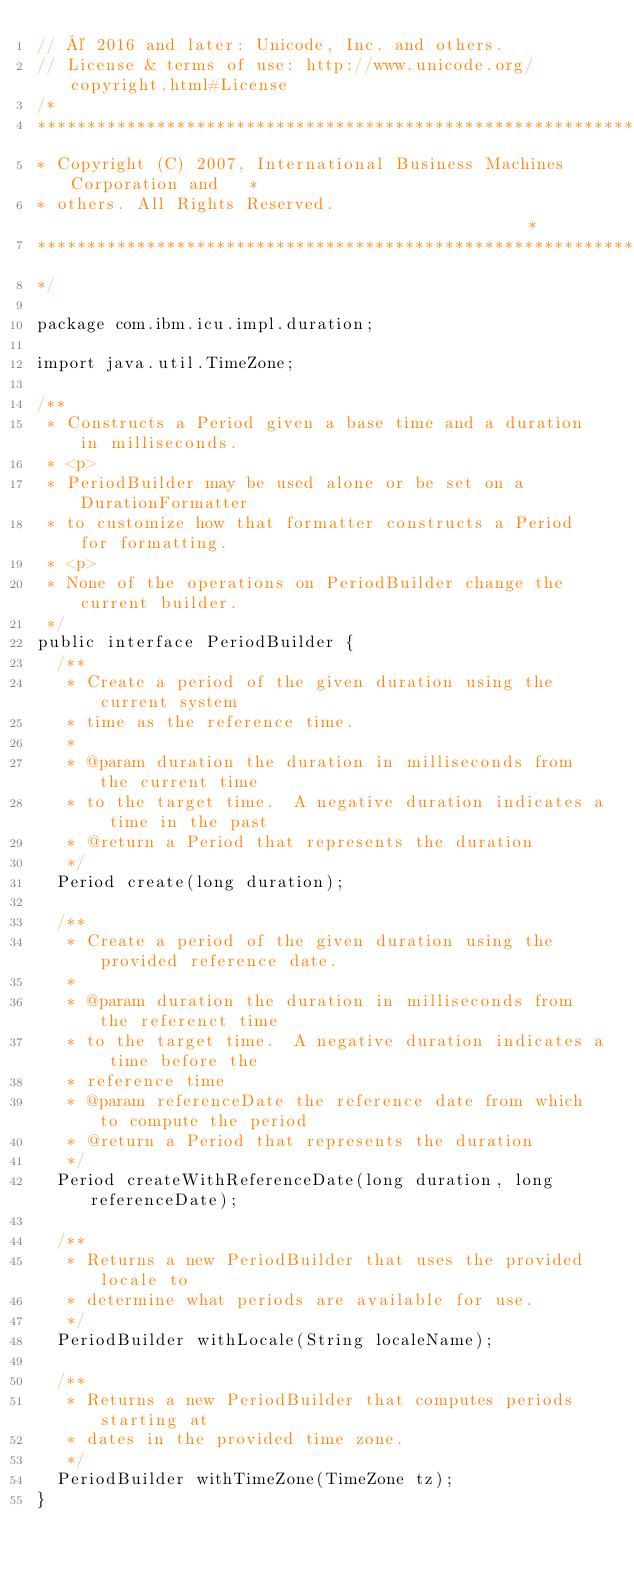Convert code to text. <code><loc_0><loc_0><loc_500><loc_500><_Java_>// © 2016 and later: Unicode, Inc. and others.
// License & terms of use: http://www.unicode.org/copyright.html#License
/*
******************************************************************************
* Copyright (C) 2007, International Business Machines Corporation and   *
* others. All Rights Reserved.                                               *
******************************************************************************
*/

package com.ibm.icu.impl.duration;

import java.util.TimeZone;

/**
 * Constructs a Period given a base time and a duration in milliseconds.
 * <p>
 * PeriodBuilder may be used alone or be set on a DurationFormatter
 * to customize how that formatter constructs a Period for formatting.
 * <p>
 * None of the operations on PeriodBuilder change the current builder.
 */
public interface PeriodBuilder {
  /**
   * Create a period of the given duration using the current system
   * time as the reference time.
   *
   * @param duration the duration in milliseconds from the current time
   * to the target time.  A negative duration indicates a time in the past
   * @return a Period that represents the duration
   */
  Period create(long duration);

  /**
   * Create a period of the given duration using the provided reference date.
   *
   * @param duration the duration in milliseconds from the referenct time
   * to the target time.  A negative duration indicates a time before the
   * reference time
   * @param referenceDate the reference date from which to compute the period
   * @return a Period that represents the duration
   */
  Period createWithReferenceDate(long duration, long referenceDate);

  /**
   * Returns a new PeriodBuilder that uses the provided locale to 
   * determine what periods are available for use.
   */
  PeriodBuilder withLocale(String localeName);

  /**
   * Returns a new PeriodBuilder that computes periods starting at
   * dates in the provided time zone.
   */
  PeriodBuilder withTimeZone(TimeZone tz);
}
</code> 